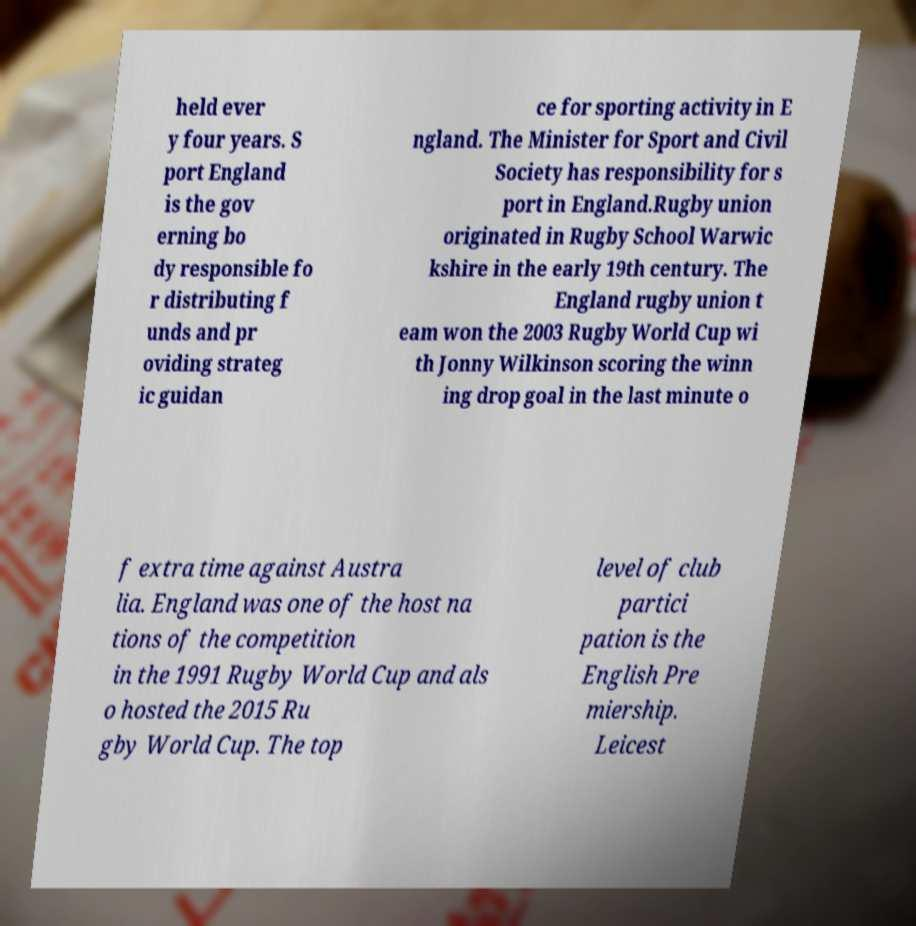Can you accurately transcribe the text from the provided image for me? held ever y four years. S port England is the gov erning bo dy responsible fo r distributing f unds and pr oviding strateg ic guidan ce for sporting activity in E ngland. The Minister for Sport and Civil Society has responsibility for s port in England.Rugby union originated in Rugby School Warwic kshire in the early 19th century. The England rugby union t eam won the 2003 Rugby World Cup wi th Jonny Wilkinson scoring the winn ing drop goal in the last minute o f extra time against Austra lia. England was one of the host na tions of the competition in the 1991 Rugby World Cup and als o hosted the 2015 Ru gby World Cup. The top level of club partici pation is the English Pre miership. Leicest 